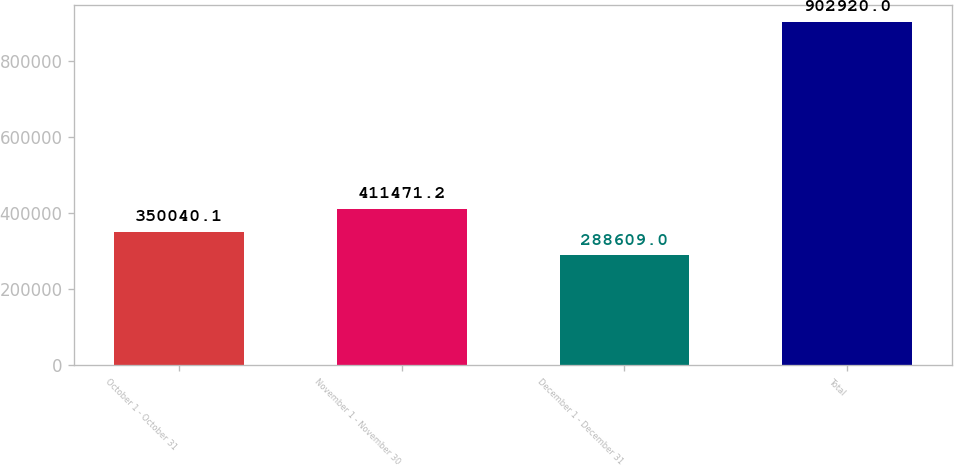<chart> <loc_0><loc_0><loc_500><loc_500><bar_chart><fcel>October 1 - October 31<fcel>November 1 - November 30<fcel>December 1 - December 31<fcel>Total<nl><fcel>350040<fcel>411471<fcel>288609<fcel>902920<nl></chart> 